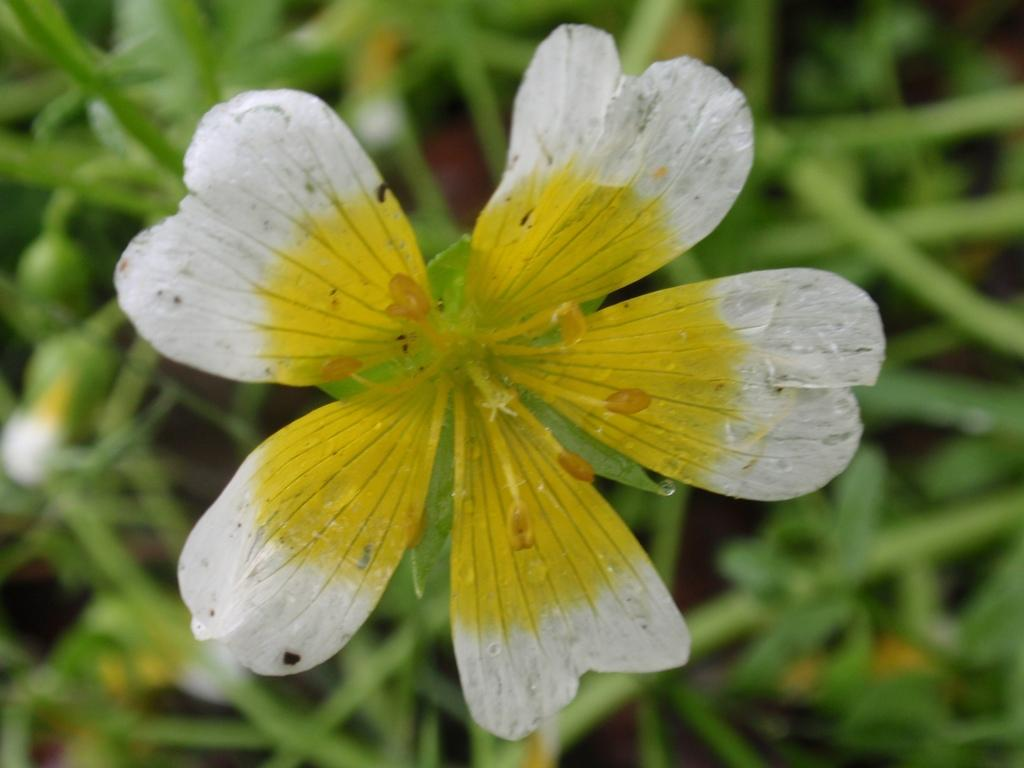What is the main subject in the center of the image? There is a flower in the center of the image. What can be seen on the left side of the image? There are buds on the left side of the image. What type of vegetation is visible in the background of the image? There are leaves visible in the background of the image. Can you tell me how many dogs are present in the image? There are no dogs present in the image; it features a flower, buds, and leaves. What type of wheel is visible in the image? There is no wheel present in the image. 